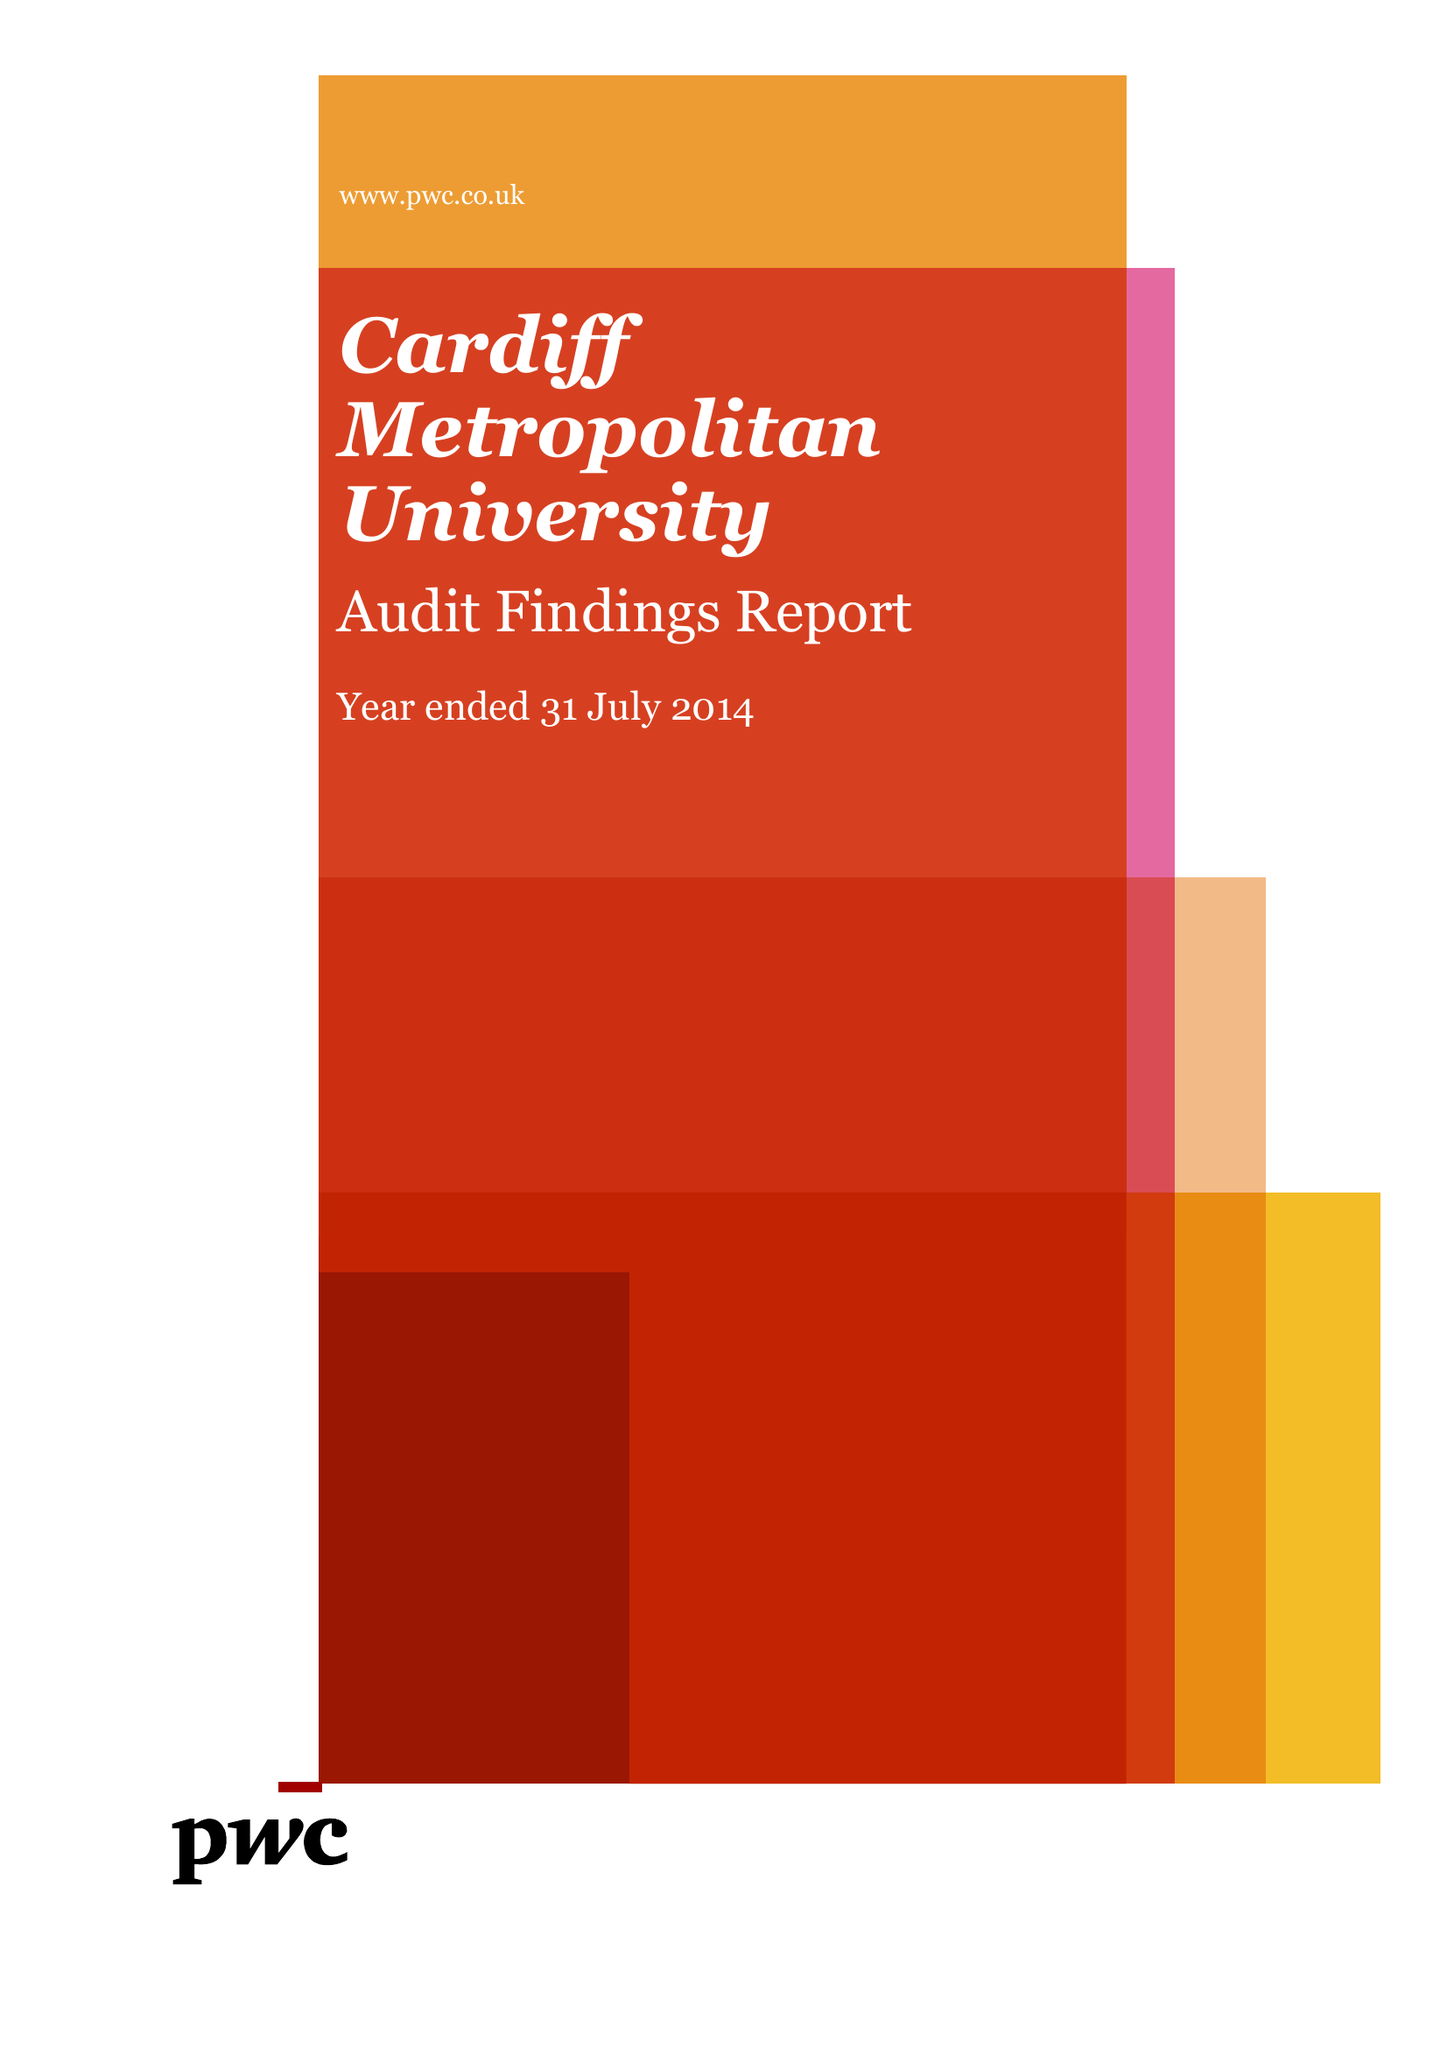What is the value for the report_date?
Answer the question using a single word or phrase. 2014-07-31 